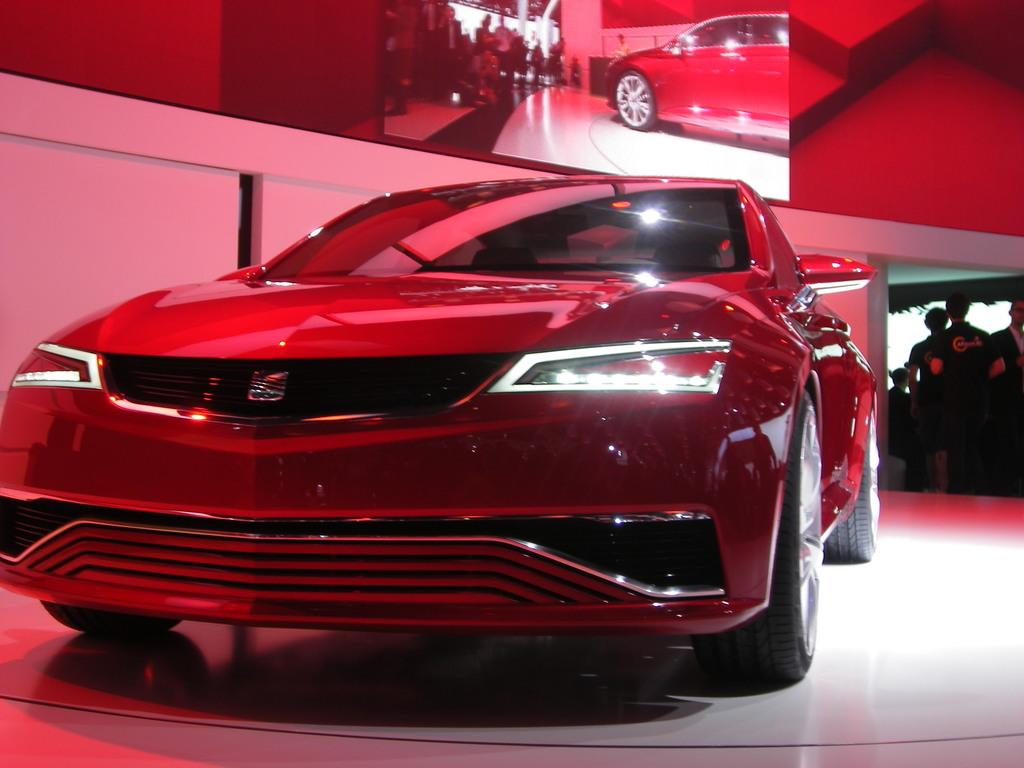What color is the car in the image? The car in the image is red. What are the people doing in the image? The people are standing on the back side of the car. Where is the rabbit hiding in the image? There is no rabbit present in the image. What type of hose is connected to the car in the image? There is no hose connected to the car in the image. 